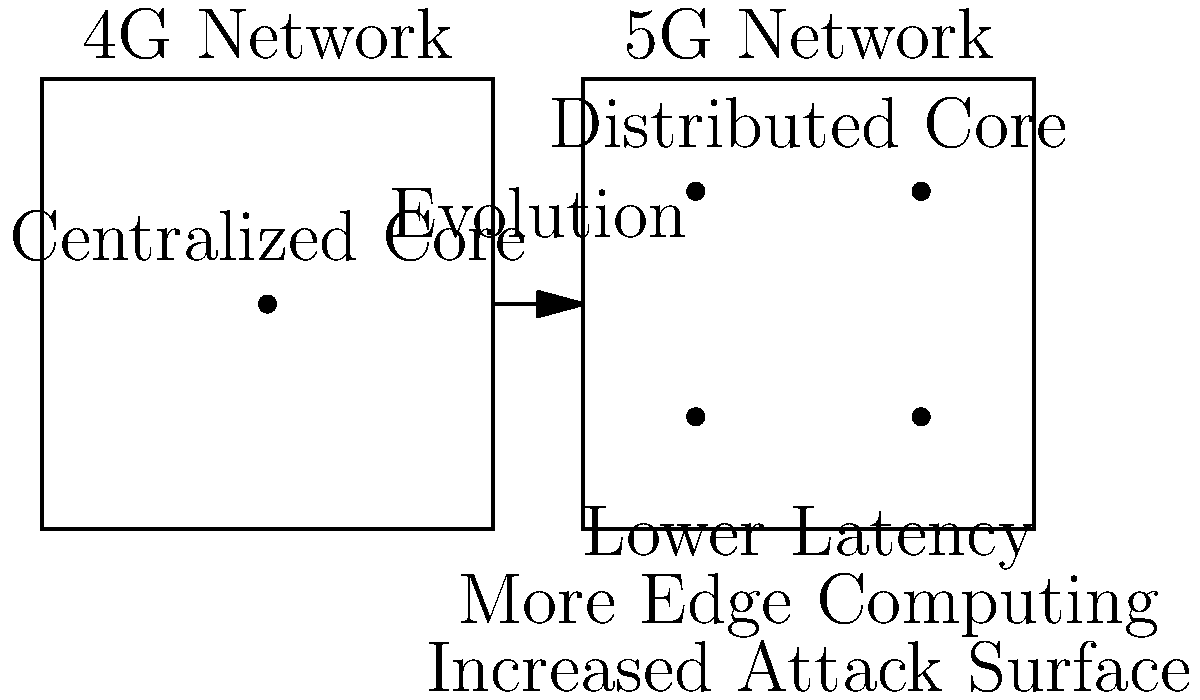Based on the diagram comparing 4G and 5G network topologies, which of the following security implications is most significant for 5G networks?

A) Centralized core vulnerability
B) Increased attack surface
C) Reduced network capacity
D) Limited edge computing capabilities To answer this question, let's analyze the diagram and the implications of the network topology changes from 4G to 5G:

1. 4G Network:
   - Shows a centralized core architecture
   - Single point represented in the network

2. 5G Network:
   - Depicts a distributed core architecture
   - Multiple points distributed across the network

3. Key differences and implications:
   a) Distributed Core: 5G moves from a centralized to a distributed core, which generally improves resilience but also increases the number of potential entry points for attackers.
   
   b) Lower Latency: This is explicitly mentioned in the diagram for 5G, which enables more real-time applications but also requires more robust security measures for time-sensitive operations.
   
   c) More Edge Computing: 5G enables increased edge computing capabilities, pushing processing closer to end-users. This can improve performance but also means that sensitive data and processes may be distributed across a wider area.
   
   d) Increased Attack Surface: This is directly stated in the diagram as a security implication for 5G. With more distributed components and edge computing, the number of potential vulnerabilities and attack vectors increases significantly.

4. Evaluating the options:
   A) Centralized core vulnerability is more applicable to 4G, not 5G.
   B) Increased attack surface directly matches the diagram and is a significant security implication of 5G's distributed architecture.
   C) Reduced network capacity is not mentioned and is actually contrary to 5G's improvements.
   D) Limited edge computing is the opposite of what 5G offers, as indicated in the diagram.

Therefore, the most significant security implication for 5G networks based on the diagram is the increased attack surface.
Answer: B) Increased attack surface 